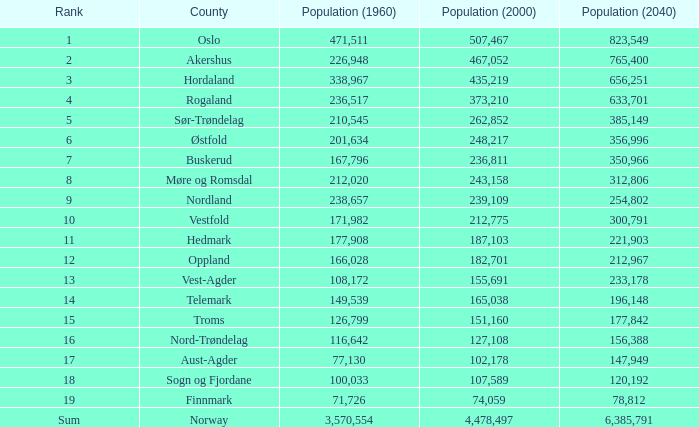In a county with a population of under 108,172 in 2000 and under 107,589 in 1960, what was the population in 2040? 2.0. Write the full table. {'header': ['Rank', 'County', 'Population (1960)', 'Population (2000)', 'Population (2040)'], 'rows': [['1', 'Oslo', '471,511', '507,467', '823,549'], ['2', 'Akershus', '226,948', '467,052', '765,400'], ['3', 'Hordaland', '338,967', '435,219', '656,251'], ['4', 'Rogaland', '236,517', '373,210', '633,701'], ['5', 'Sør-Trøndelag', '210,545', '262,852', '385,149'], ['6', 'Østfold', '201,634', '248,217', '356,996'], ['7', 'Buskerud', '167,796', '236,811', '350,966'], ['8', 'Møre og Romsdal', '212,020', '243,158', '312,806'], ['9', 'Nordland', '238,657', '239,109', '254,802'], ['10', 'Vestfold', '171,982', '212,775', '300,791'], ['11', 'Hedmark', '177,908', '187,103', '221,903'], ['12', 'Oppland', '166,028', '182,701', '212,967'], ['13', 'Vest-Agder', '108,172', '155,691', '233,178'], ['14', 'Telemark', '149,539', '165,038', '196,148'], ['15', 'Troms', '126,799', '151,160', '177,842'], ['16', 'Nord-Trøndelag', '116,642', '127,108', '156,388'], ['17', 'Aust-Agder', '77,130', '102,178', '147,949'], ['18', 'Sogn og Fjordane', '100,033', '107,589', '120,192'], ['19', 'Finnmark', '71,726', '74,059', '78,812'], ['Sum', 'Norway', '3,570,554', '4,478,497', '6,385,791']]} 